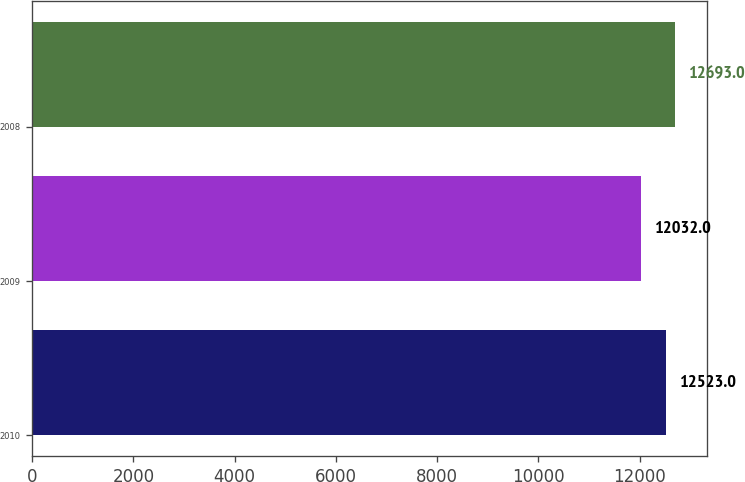Convert chart to OTSL. <chart><loc_0><loc_0><loc_500><loc_500><bar_chart><fcel>2010<fcel>2009<fcel>2008<nl><fcel>12523<fcel>12032<fcel>12693<nl></chart> 